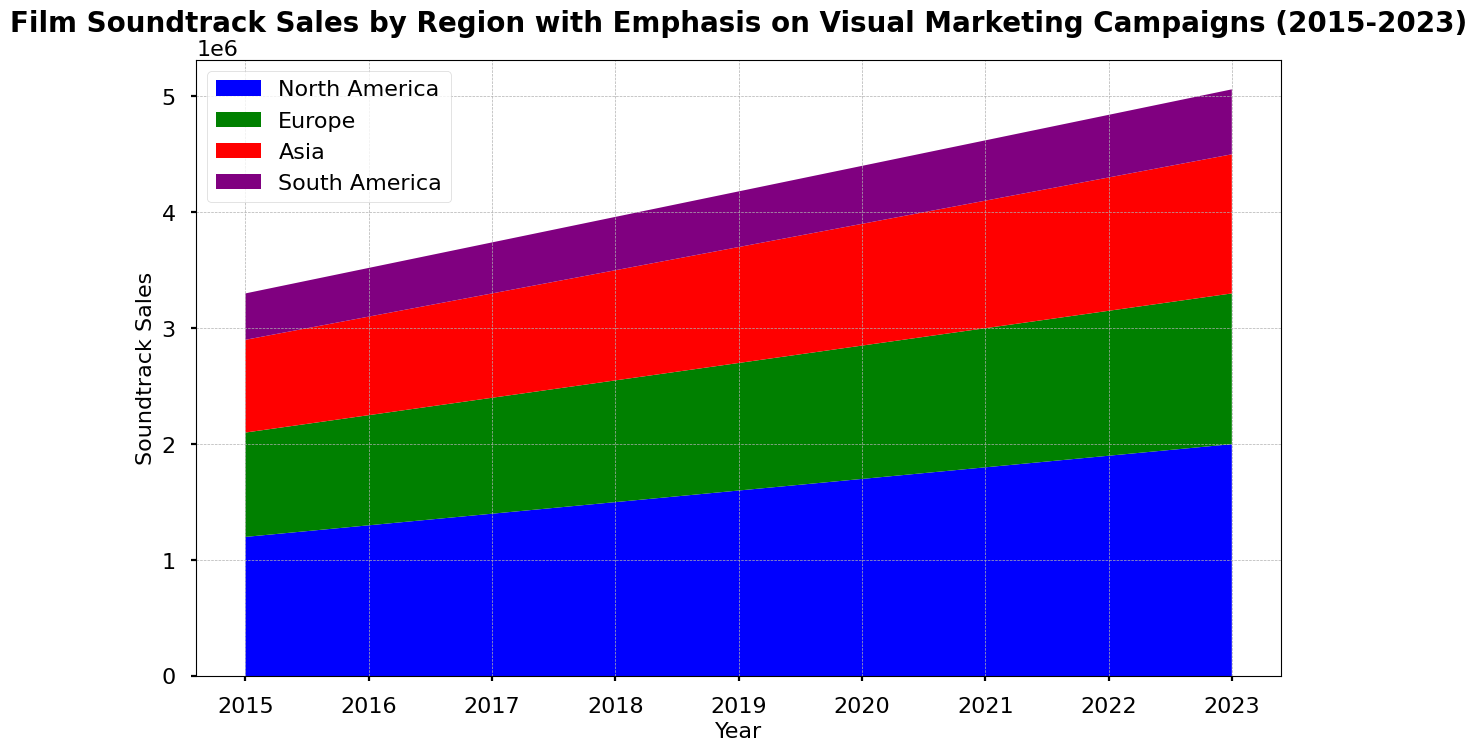What is the general trend in soundtrack sales in North America from 2015 to 2023? Observing the area chart, the height of the blue section representing North America increases consistently from 2015 to 2023, indicating a steadily rising trend in soundtrack sales in this region.
Answer: Increasing Which region had the smallest soundtrack sales in 2015, and how do you know? The purple section which represents South America is the smallest area section in 2015, indicating that South America had the smallest soundtrack sales in that year.
Answer: South America Between 2018 and 2021, which region showed the most significant increase in soundtrack sales? By comparing the areas between 2018 and 2021, the blue section (North America) shows the greatest vertical expansion, indicating that North America had the most significant increase in soundtrack sales during this period.
Answer: North America Comparing 2015 and 2023, which region had the most considerable percentage increase in soundtrack sales? By examining the changes in area size, Asia (red section) and North America (blue section) both show significant growth, but North America's increase from 1,200,000 to 2,000,000 is the largest absolute and percentage gain. Calculate (2,000,000-1,200,000)/1,200,000 = approximately 0.67 or 67%.
Answer: North America Has the visual marketing spending correlated with an increase in soundtrack sales for any region? How can you infer this from the figure? The regions where the area representing soundtrack sales grows visibly alongside time (especially North America and Europe, seen in blue and green) imply a potential correlation with increased visual marketing efforts, as these regions had higher initial marketing spends and soundtrack sales increased significantly as marketing spending increased over the years.
Answer: Yes, especially North America and Europe Which year shows the highest overall soundtrack sales across all regions combined, and how can you tell? The area chart showcases the combined height of all regions. The tallest stacked areas occur in 2023, indicating this year has the highest overall soundtrack sales across all regions.
Answer: 2023 What is the combined soundtrack sales for all regions in 2019? To find the combined sales for 2019, sum the heights of the individual regions for that year. (1,600,000 + 1,100,000 + 1,000,000 + 480,000) gives a total of 4,180,000.
Answer: 4,180,000 